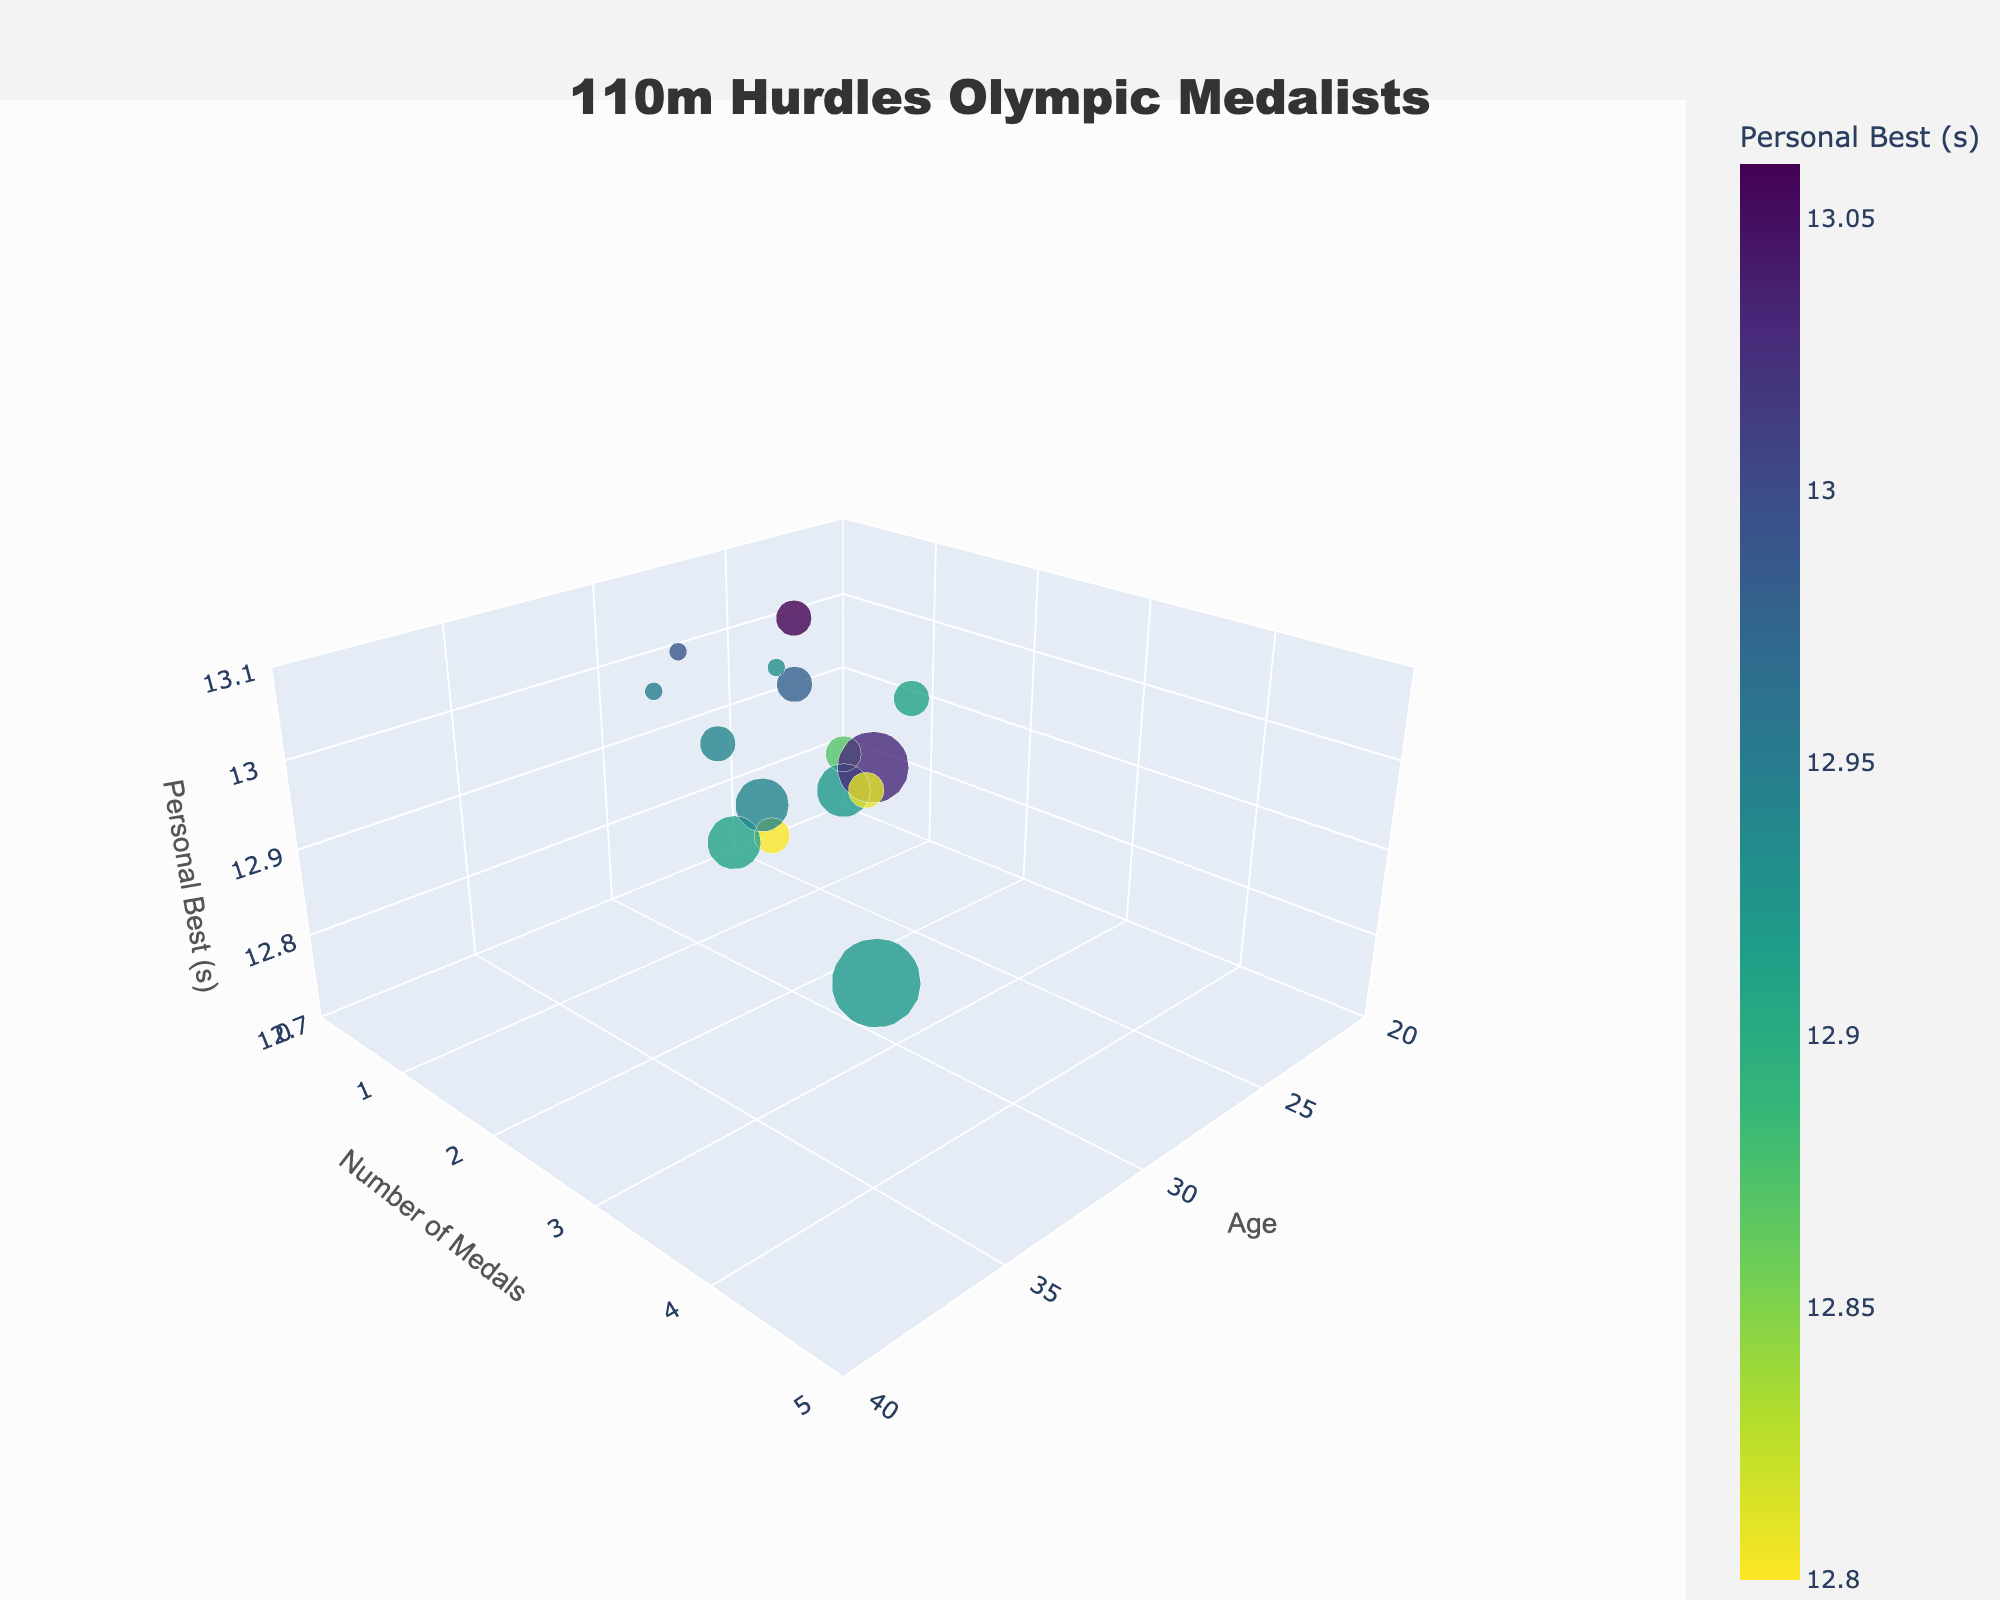How many data points are there in the chart? Count the total number of bubbles in the chart. Each bubble represents one data point corresponding to an athlete.
Answer: 15 What is the range of ages displayed in the chart? Observe the x-axis which represents the age of athletes. The lowest and highest values are the endpoints of the range. In the chart, the ages range from approximately 20 to 40.
Answer: 20 to 40 Which athlete has the fastest personal best time? Look for the bubble with the lowest z-axis value, as the z-axis represents personal best times in seconds. The athlete with the lowest time would be Aries Merritt with a personal best of 12.80 seconds.
Answer: Aries Merritt What is the median age of the medal-winning athletes? To find the median age, list the ages in ascending order: (21, 23, 24, 26, 26, 27, 27, 28, 28, 29, 31, 31, 32, 35, 35). With 15 data points, the median is the 8th value in the sequence.
Answer: 28 Which athlete has won the most medals and how many have they won? Identify the bubble with the highest y-axis value, representing the number of medals. Allen Johnson has the most medals, with a total of 4.
Answer: Allen Johnson, 4 Compare the personal best times of Liu Xiang and Grant Holloway. Who has the better time and by how much? Compare their z-axis values. Liu Xiang has a personal best of 12.91 seconds and Grant Holloway has a personal best of 12.81 seconds. Grant Holloway's time is faster by (12.91 - 12.81) = 0.10 seconds.
Answer: Grant Holloway, 0.10 seconds What is the average number of medals won by athletes aged 28? Locate athletes aged 28 on the x-axis and look at their corresponding y-axis values for medals. Roger Kingdom and Pascal Martinot-Lagarde each have 2 and 0 medals respectively. Calculate the average: (2 + 0) / 2 = 1 medal.
Answer: 1 Is there a correlation between age and personal best times? Check if there is any visible pattern between the x-axis (age) and the z-axis (personal best times). Generally, personal best times do not show a strong consistent trend with age, indicating a weak or no clear correlation.
Answer: Weak or no clear correlation How many athletes have their personal best times under 12.90 seconds? Look for the bubbles below the 12.90 mark on the z-axis. Count the corresponding data points: Aries Merritt, Dayron Robles, Grant Holloway, and Renaldo Nehemiah.
Answer: 4 Are there more medalists in their 20s or their 30s? Identify the number of medalists and their ages. Count how many are in their 20s (21, 23, 24, 26 (2), 27 (2), 28 (2), 29) and in their 30s (31 (2), 32, 35). There are 9 medalists in their 20s and 5 medalists in their 30s.
Answer: 20s 